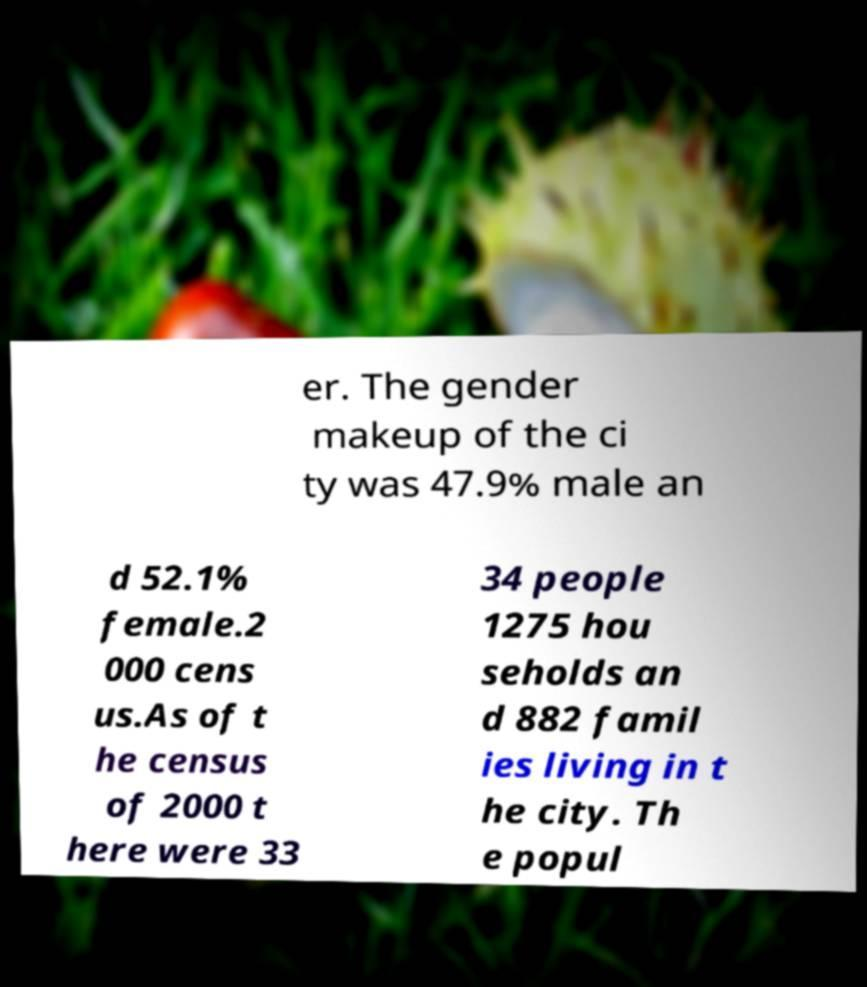Could you assist in decoding the text presented in this image and type it out clearly? er. The gender makeup of the ci ty was 47.9% male an d 52.1% female.2 000 cens us.As of t he census of 2000 t here were 33 34 people 1275 hou seholds an d 882 famil ies living in t he city. Th e popul 